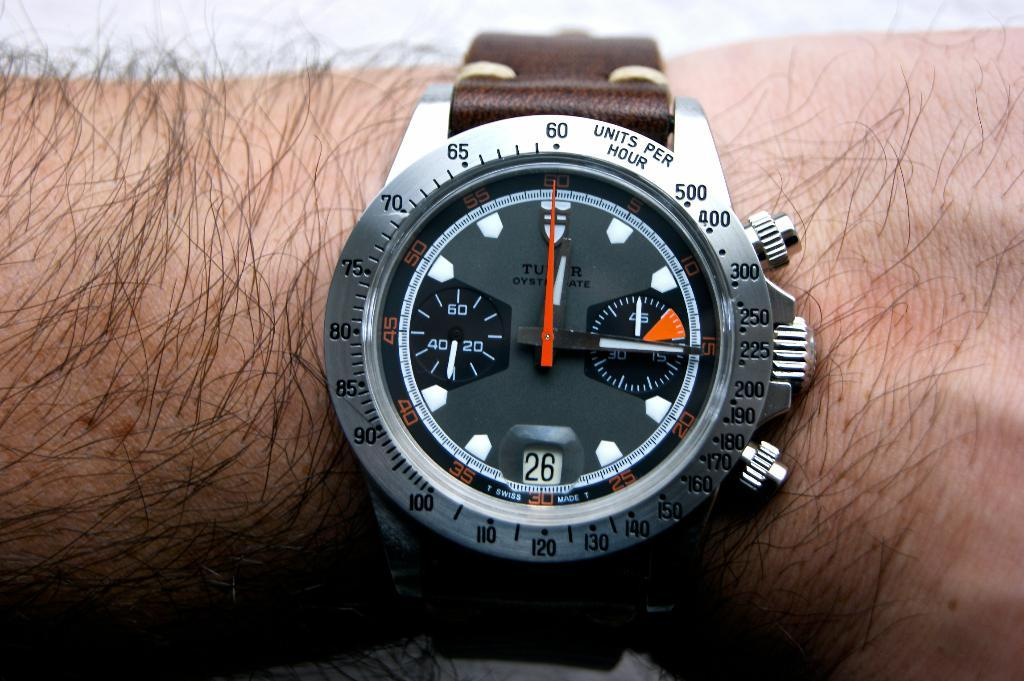Provide a one-sentence caption for the provided image. The watch on the man's arm is showing that it's the 26th day of the month. 